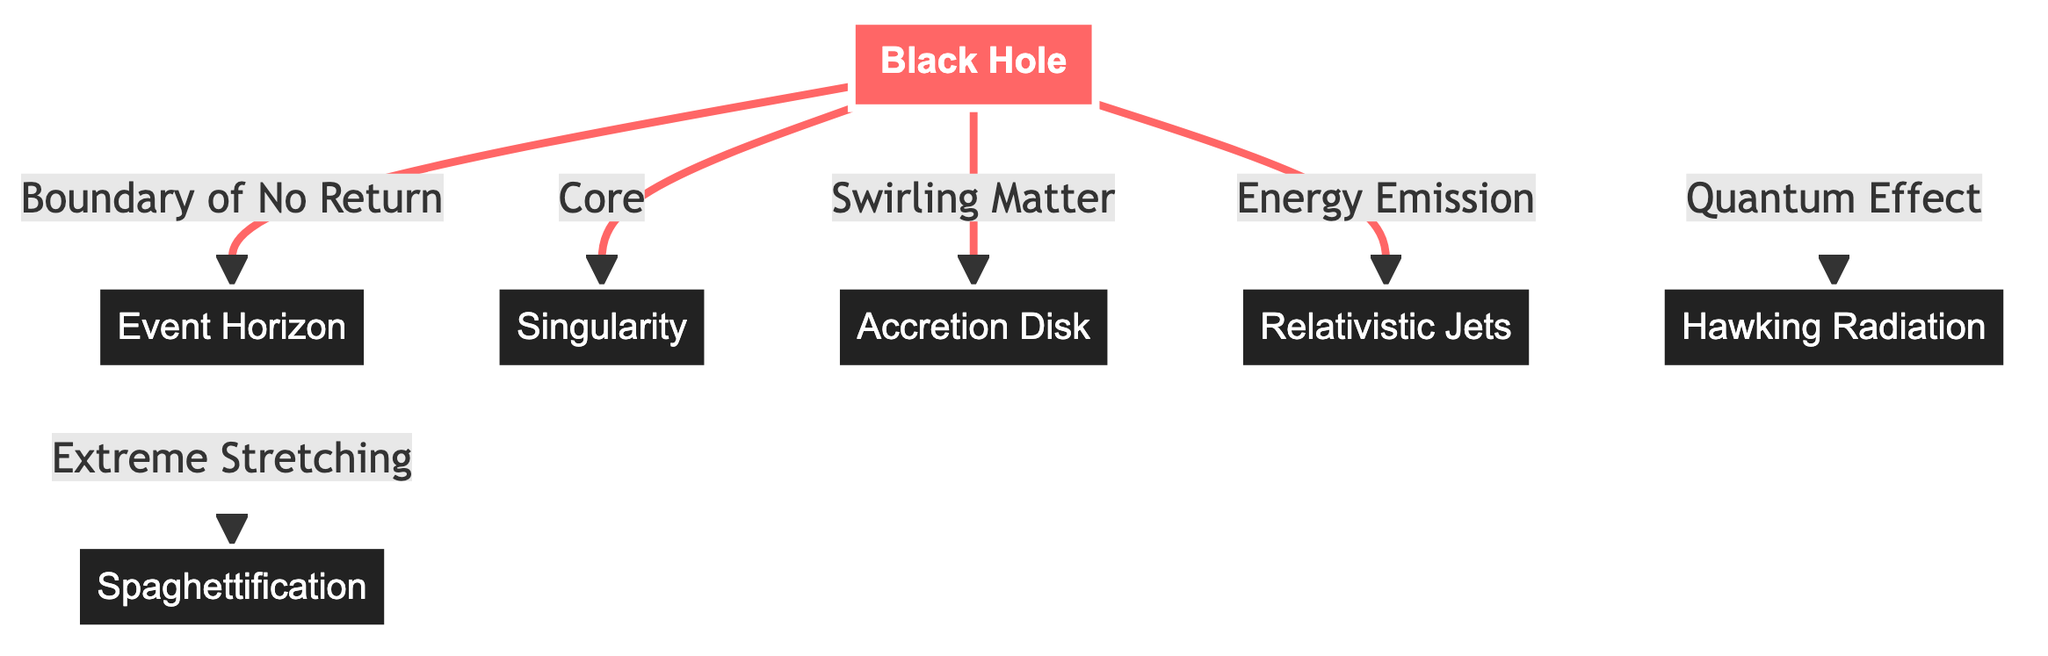What is the event horizon? The event horizon is labeled on the diagram and is the boundary of no return surrounding the black hole, indicating where the escape velocity exceeds the speed of light.
Answer: Boundary of No Return What connects the black hole to the accretion disk? The diagram shows an arrow from the black hole to the accretion disk indicating that the energy and matter from the black hole contribute to the swirling matter present in the accretion disk.
Answer: Swirling Matter How many main components are directly linked to the black hole? The diagram shows five components that are directly linked to the black hole: event horizon, singularity, accretion disk, relativistic jets, and Hawking radiation.
Answer: Five What phenomenon occurs at the event horizon? The diagram specifies that extreme stretching occurs at the event horizon, illustrating the gravitational effects experienced near this boundary.
Answer: Extreme Stretching What is emitted as energy from the black hole? According to the diagram, relativistic jets are emitted from the black hole as energy, demonstrating the black hole's impact on surrounding matter.
Answer: Relativistic Jets What is spaghettification? The diagram describes spaghettification as a phenomenon occurring at the event horizon, where objects are stretched and compressed due to strong gravitational forces.
Answer: Extreme Stretching What is the core of the black hole referred to as? The core of the black hole is labeled as singularity in the diagram, representing the region where density becomes infinite.
Answer: Singularity What is a unique quantum effect associated with black holes? The diagram indicates Hawking radiation as a quantum effect associated with black holes, showcasing the theoretical radiation predicted by Stephen Hawking.
Answer: Hawking Radiation How does matter interact with the event horizon? Matter experiences extreme stretching as it approaches the event horizon, leading to the concept of spaghettification as shown in the diagram.
Answer: Spaghettification 